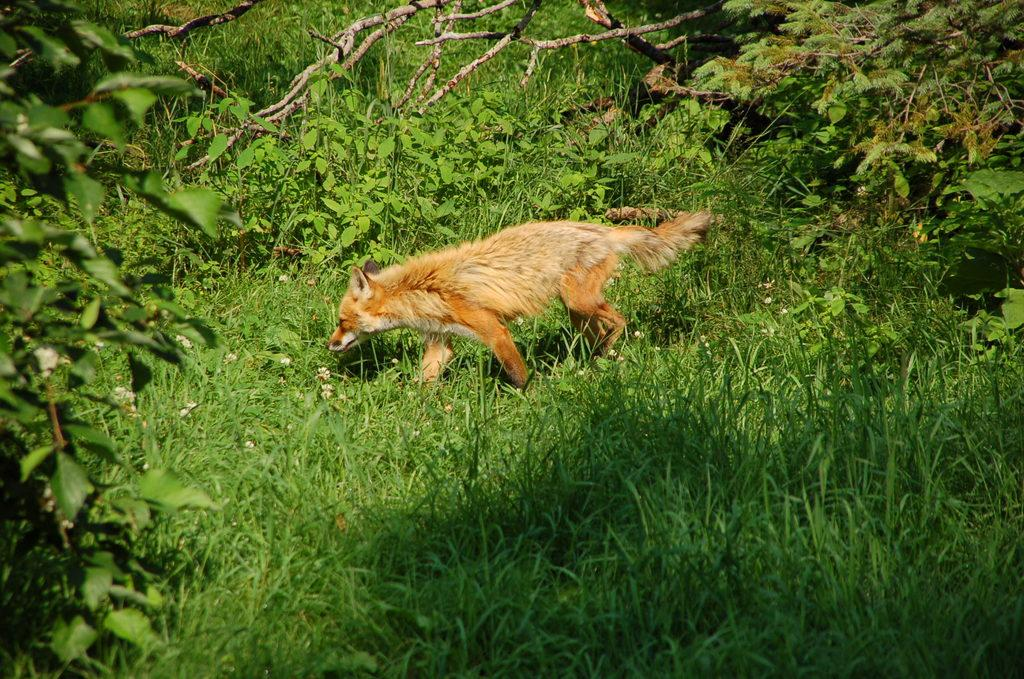What type of animal is in the image? There is a dog in the image. What is the surrounding environment like for the dog? There is a lot of grass around the dog. What other living organisms can be seen in the image? There are plants in the image. What type of nail polish is the dog wearing in the image? There is no nail polish present on the dog in the image. What type of berry can be seen growing on the dog in the image? There are no berries present on the dog in the image. 